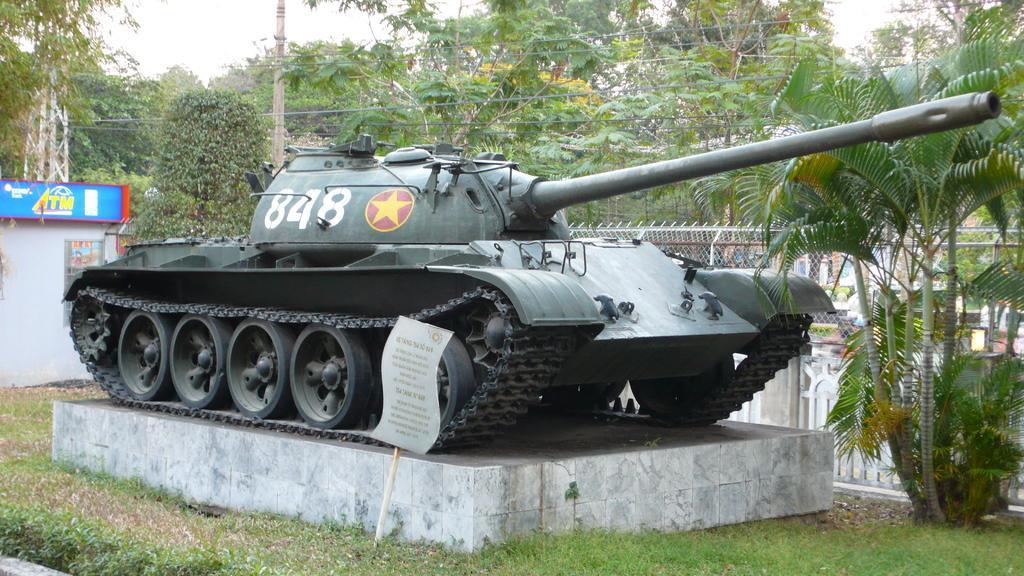How would you summarize this image in a sentence or two? This is grass. Here we can see a military vehicle, boards, fence, pole, and trees. In the background there is sky. 